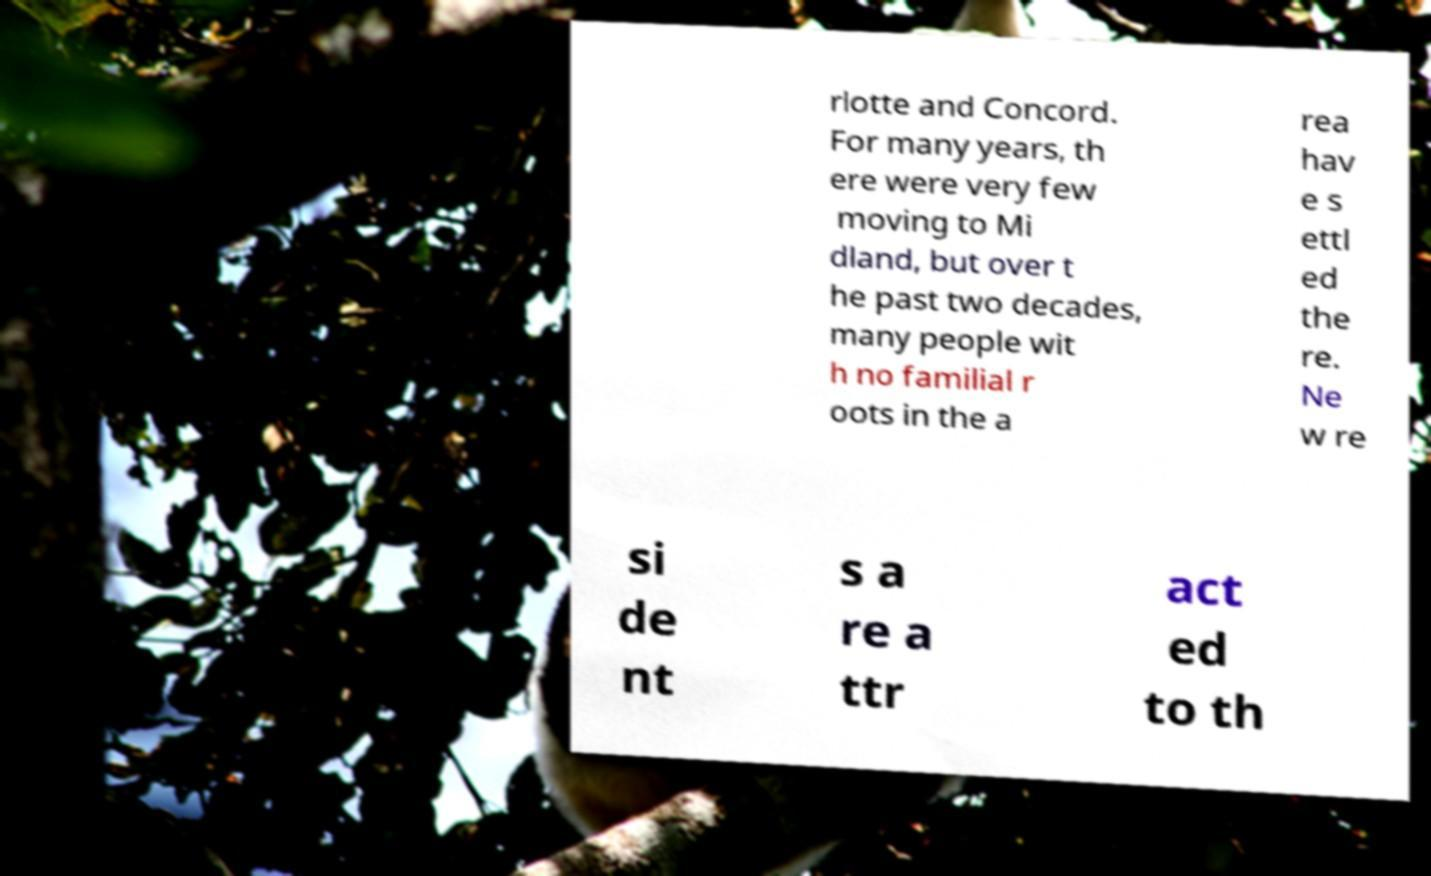For documentation purposes, I need the text within this image transcribed. Could you provide that? rlotte and Concord. For many years, th ere were very few moving to Mi dland, but over t he past two decades, many people wit h no familial r oots in the a rea hav e s ettl ed the re. Ne w re si de nt s a re a ttr act ed to th 